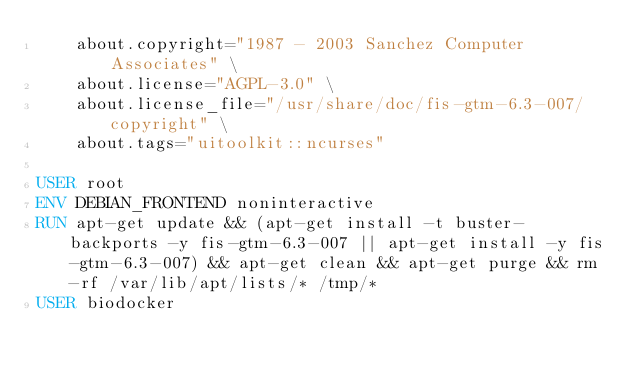Convert code to text. <code><loc_0><loc_0><loc_500><loc_500><_Dockerfile_>    about.copyright="1987 - 2003 Sanchez Computer Associates" \ 
    about.license="AGPL-3.0" \ 
    about.license_file="/usr/share/doc/fis-gtm-6.3-007/copyright" \ 
    about.tags="uitoolkit::ncurses" 

USER root
ENV DEBIAN_FRONTEND noninteractive
RUN apt-get update && (apt-get install -t buster-backports -y fis-gtm-6.3-007 || apt-get install -y fis-gtm-6.3-007) && apt-get clean && apt-get purge && rm -rf /var/lib/apt/lists/* /tmp/*
USER biodocker
</code> 